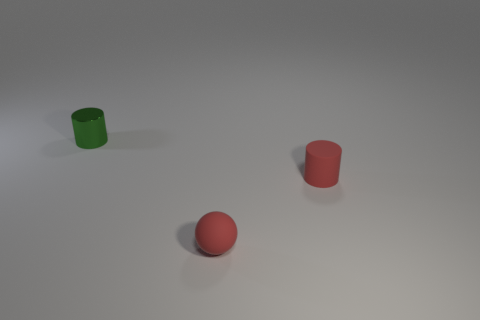What shape is the thing that is the same color as the small rubber ball? The object sharing the same color as the small rubber ball is a cylinder. Specifically, it's a red cylindrical cup with an open top, resembling a simplified drinking glass or container. 